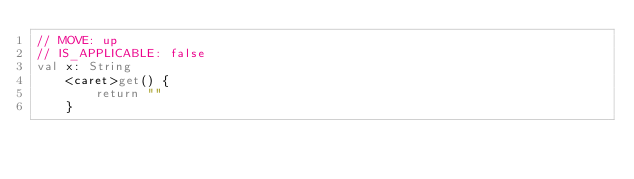<code> <loc_0><loc_0><loc_500><loc_500><_Kotlin_>// MOVE: up
// IS_APPLICABLE: false
val x: String
    <caret>get() {
        return ""
    }</code> 